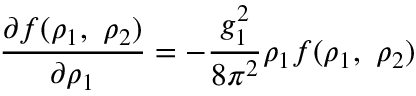Convert formula to latex. <formula><loc_0><loc_0><loc_500><loc_500>\frac { \partial f ( \rho _ { 1 } , \rho _ { 2 } ) } { \partial \rho _ { 1 } } = - \frac { g _ { 1 } ^ { 2 } } { 8 \pi ^ { 2 } } \rho _ { 1 } f ( \rho _ { 1 } , \rho _ { 2 } )</formula> 